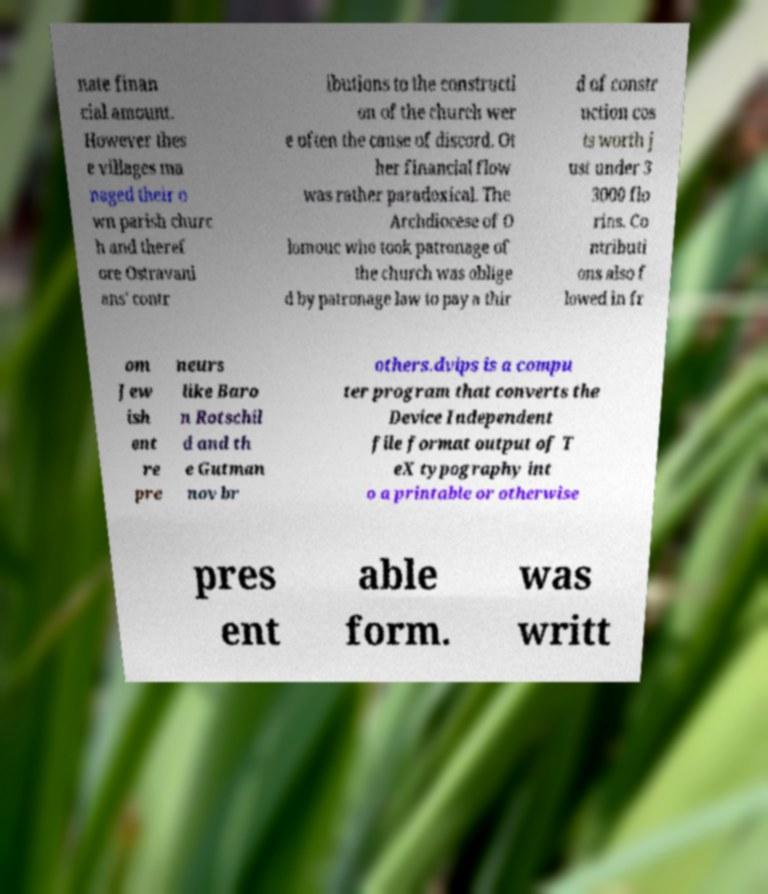Please read and relay the text visible in this image. What does it say? nate finan cial amount. However thes e villages ma naged their o wn parish churc h and theref ore Ostravani ans' contr ibutions to the constructi on of the church wer e often the cause of discord. Ot her financial flow was rather paradoxical. The Archdiocese of O lomouc who took patronage of the church was oblige d by patronage law to pay a thir d of constr uction cos ts worth j ust under 3 3000 flo rins. Co ntributi ons also f lowed in fr om Jew ish ent re pre neurs like Baro n Rotschil d and th e Gutman nov br others.dvips is a compu ter program that converts the Device Independent file format output of T eX typography int o a printable or otherwise pres ent able form. was writt 